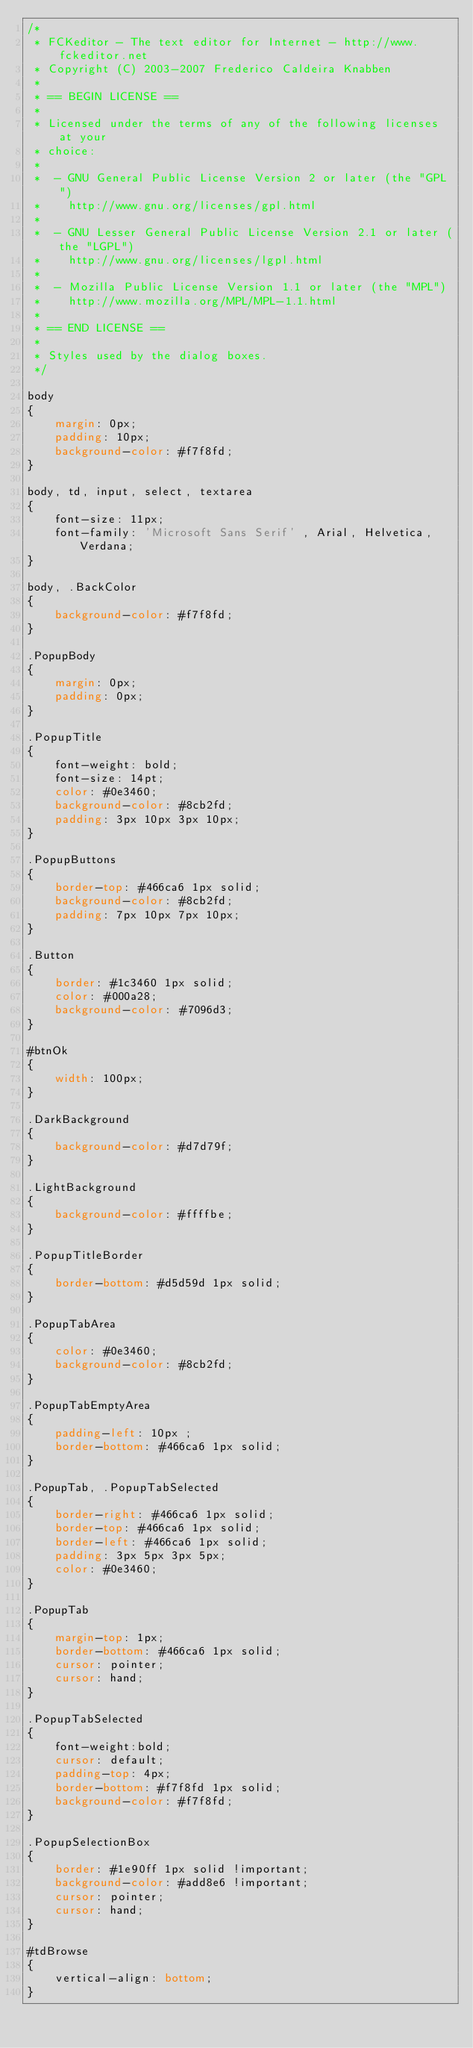Convert code to text. <code><loc_0><loc_0><loc_500><loc_500><_CSS_>/*
 * FCKeditor - The text editor for Internet - http://www.fckeditor.net
 * Copyright (C) 2003-2007 Frederico Caldeira Knabben
 *
 * == BEGIN LICENSE ==
 *
 * Licensed under the terms of any of the following licenses at your
 * choice:
 *
 *  - GNU General Public License Version 2 or later (the "GPL")
 *    http://www.gnu.org/licenses/gpl.html
 *
 *  - GNU Lesser General Public License Version 2.1 or later (the "LGPL")
 *    http://www.gnu.org/licenses/lgpl.html
 *
 *  - Mozilla Public License Version 1.1 or later (the "MPL")
 *    http://www.mozilla.org/MPL/MPL-1.1.html
 *
 * == END LICENSE ==
 *
 * Styles used by the dialog boxes.
 */

body
{
	margin: 0px;
	padding: 10px;
	background-color: #f7f8fd;
}

body, td, input, select, textarea
{
	font-size: 11px;
	font-family: 'Microsoft Sans Serif' , Arial, Helvetica, Verdana;
}

body, .BackColor
{
	background-color: #f7f8fd;
}

.PopupBody
{
	margin: 0px;
	padding: 0px;
}

.PopupTitle
{
	font-weight: bold;
	font-size: 14pt;
	color: #0e3460;
	background-color: #8cb2fd;
	padding: 3px 10px 3px 10px;
}

.PopupButtons
{
	border-top: #466ca6 1px solid;
	background-color: #8cb2fd;
	padding: 7px 10px 7px 10px;
}

.Button
{
	border: #1c3460 1px solid;
	color: #000a28;
	background-color: #7096d3;
}

#btnOk
{
	width: 100px;
}

.DarkBackground
{
	background-color: #d7d79f;
}

.LightBackground
{
	background-color: #ffffbe;
}

.PopupTitleBorder
{
	border-bottom: #d5d59d 1px solid;
}

.PopupTabArea
{
	color: #0e3460;
	background-color: #8cb2fd;
}

.PopupTabEmptyArea
{
	padding-left: 10px ;
	border-bottom: #466ca6 1px solid;
}

.PopupTab, .PopupTabSelected
{
	border-right: #466ca6 1px solid;
	border-top: #466ca6 1px solid;
	border-left: #466ca6 1px solid;
	padding: 3px 5px 3px 5px;
	color: #0e3460;
}

.PopupTab
{
	margin-top: 1px;
	border-bottom: #466ca6 1px solid;
	cursor: pointer;
	cursor: hand;
}

.PopupTabSelected
{
	font-weight:bold;
	cursor: default;
	padding-top: 4px;
	border-bottom: #f7f8fd 1px solid;
	background-color: #f7f8fd;
}

.PopupSelectionBox
{
	border: #1e90ff 1px solid !important;
	background-color: #add8e6 !important;
	cursor: pointer;
	cursor: hand;
}

#tdBrowse 
{
	vertical-align: bottom;
}</code> 